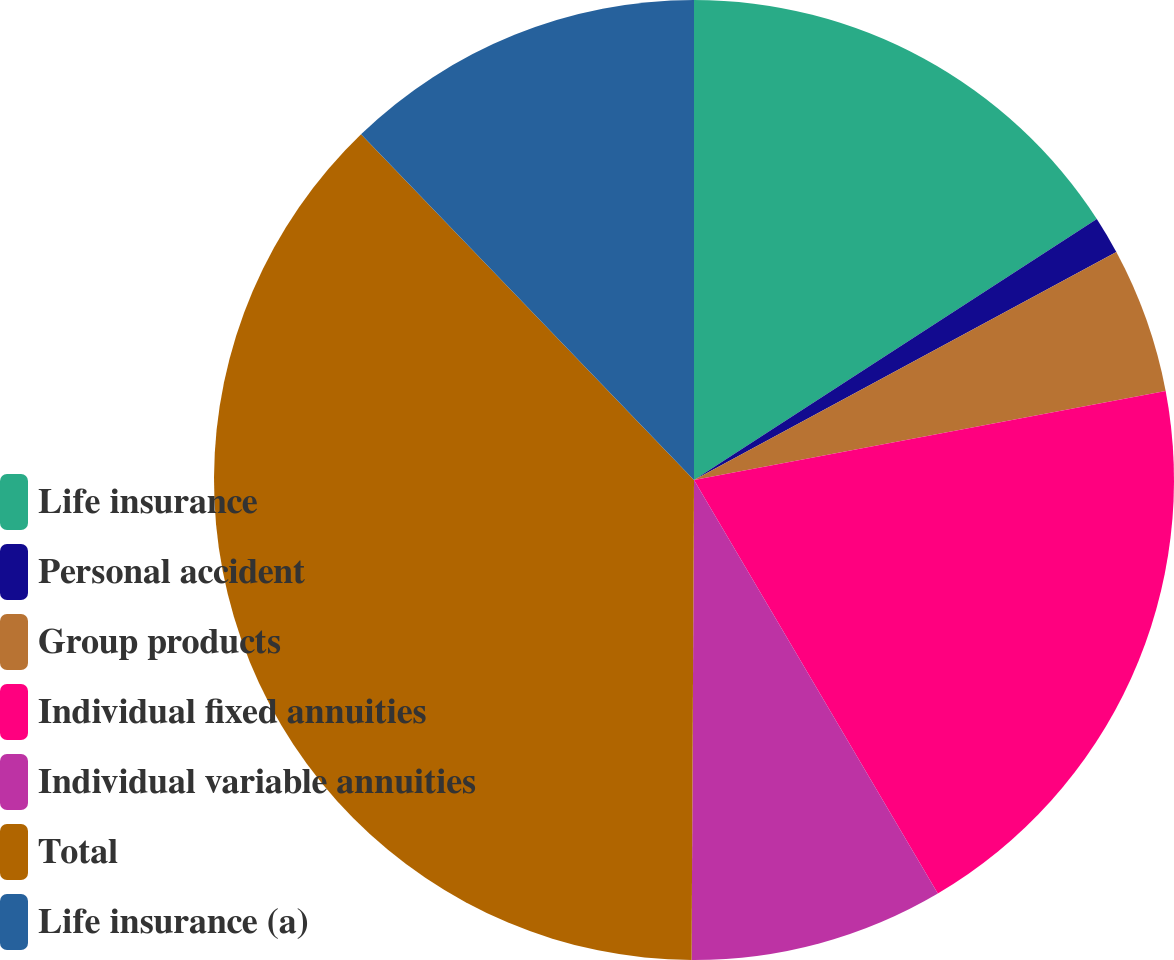Convert chart. <chart><loc_0><loc_0><loc_500><loc_500><pie_chart><fcel>Life insurance<fcel>Personal accident<fcel>Group products<fcel>Individual fixed annuities<fcel>Individual variable annuities<fcel>Total<fcel>Life insurance (a)<nl><fcel>15.85%<fcel>1.27%<fcel>4.91%<fcel>19.49%<fcel>8.56%<fcel>37.72%<fcel>12.2%<nl></chart> 